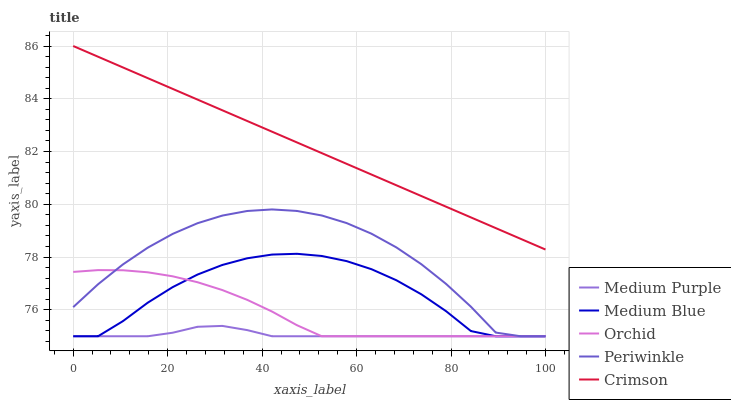Does Medium Purple have the minimum area under the curve?
Answer yes or no. Yes. Does Crimson have the maximum area under the curve?
Answer yes or no. Yes. Does Periwinkle have the minimum area under the curve?
Answer yes or no. No. Does Periwinkle have the maximum area under the curve?
Answer yes or no. No. Is Crimson the smoothest?
Answer yes or no. Yes. Is Medium Blue the roughest?
Answer yes or no. Yes. Is Periwinkle the smoothest?
Answer yes or no. No. Is Periwinkle the roughest?
Answer yes or no. No. Does Crimson have the lowest value?
Answer yes or no. No. Does Crimson have the highest value?
Answer yes or no. Yes. Does Periwinkle have the highest value?
Answer yes or no. No. Is Medium Purple less than Crimson?
Answer yes or no. Yes. Is Crimson greater than Periwinkle?
Answer yes or no. Yes. Does Medium Purple intersect Crimson?
Answer yes or no. No. 